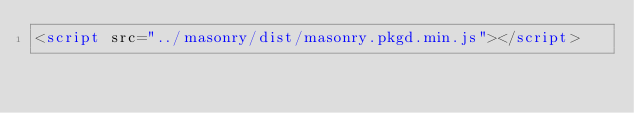<code> <loc_0><loc_0><loc_500><loc_500><_HTML_><script src="../masonry/dist/masonry.pkgd.min.js"></script></code> 